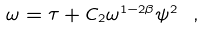Convert formula to latex. <formula><loc_0><loc_0><loc_500><loc_500>\omega = \tau + C _ { 2 } \omega ^ { 1 - 2 \beta } \psi ^ { 2 } \ ,</formula> 